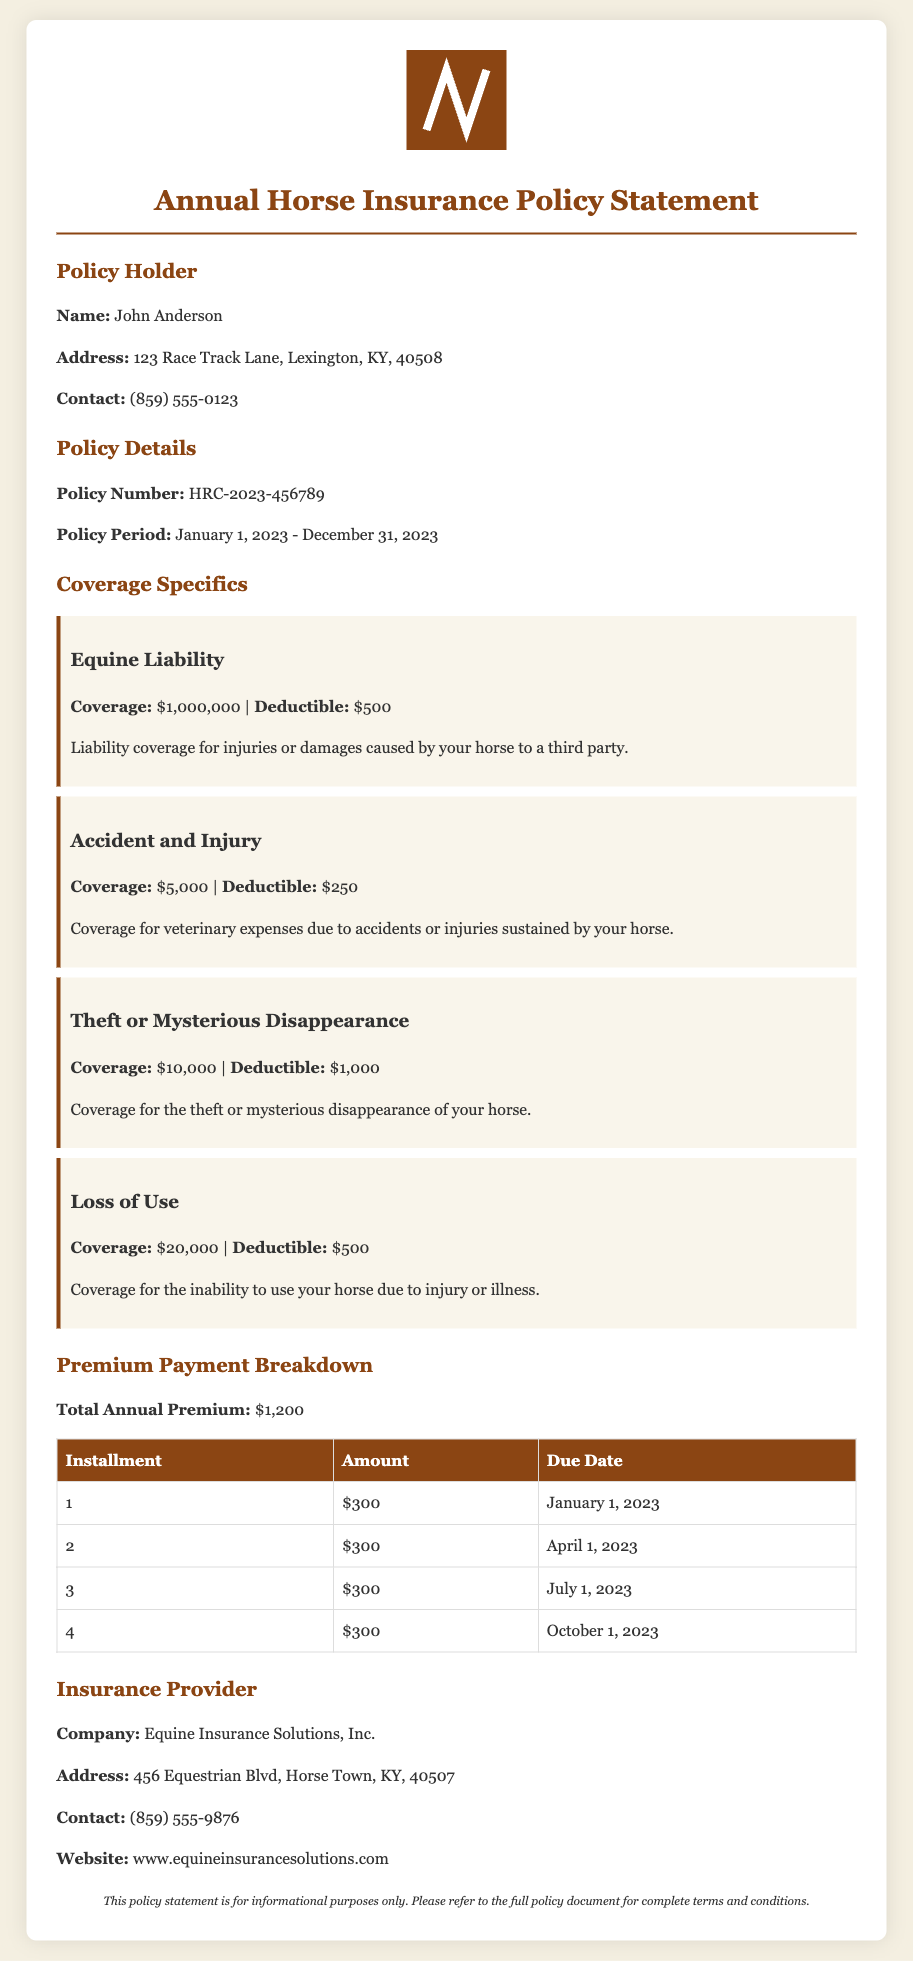What is the policy holder's name? The policy holder's name is explicitly stated in the document.
Answer: John Anderson What is the total annual premium? The total annual premium is clearly listed in the premium payment breakdown section.
Answer: $1,200 What is the coverage amount for Theft or Mysterious Disappearance? The coverage amount for Theft or Mysterious Disappearance is specified in the coverage specifics section.
Answer: $10,000 When is the second premium installment due? The due date for the second installment is mentioned in the payment breakdown table.
Answer: April 1, 2023 What is the deductible for Equine Liability coverage? The deductible amount is provided alongside the coverage details for Equine Liability.
Answer: $500 Which company provides this insurance policy? The document indicates the name of the insurance provider.
Answer: Equine Insurance Solutions, Inc How many installments are there for the annual premium? The number of installments can be inferred from the payment breakdown table.
Answer: 4 What type of coverage is included for injuries or damages caused by your horse? The specific coverage type is explained in the coverage specifics section.
Answer: Equine Liability What is the policy number? The policy number is uniquely identified in the policy details section.
Answer: HRC-2023-456789 